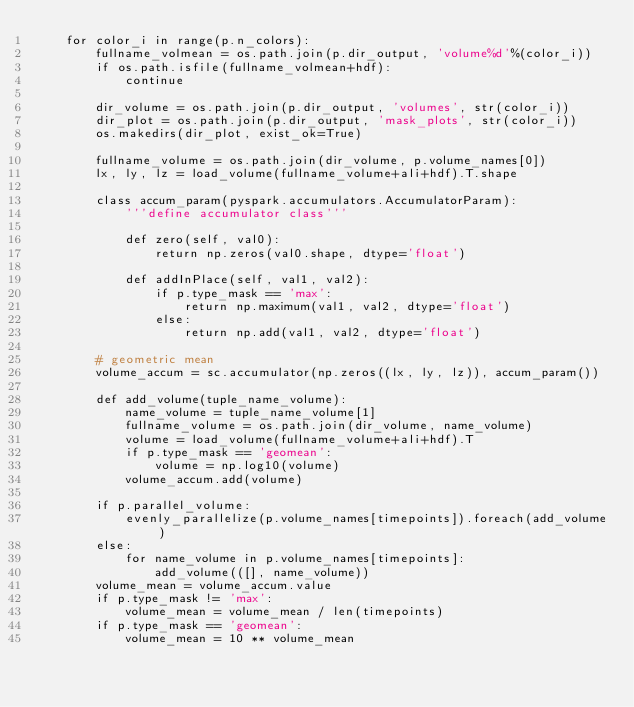<code> <loc_0><loc_0><loc_500><loc_500><_Python_>    for color_i in range(p.n_colors):
        fullname_volmean = os.path.join(p.dir_output, 'volume%d'%(color_i))
        if os.path.isfile(fullname_volmean+hdf):
            continue

        dir_volume = os.path.join(p.dir_output, 'volumes', str(color_i))
        dir_plot = os.path.join(p.dir_output, 'mask_plots', str(color_i))
        os.makedirs(dir_plot, exist_ok=True)

        fullname_volume = os.path.join(dir_volume, p.volume_names[0])
        lx, ly, lz = load_volume(fullname_volume+ali+hdf).T.shape

        class accum_param(pyspark.accumulators.AccumulatorParam):
            '''define accumulator class'''

            def zero(self, val0):
                return np.zeros(val0.shape, dtype='float')

            def addInPlace(self, val1, val2):
                if p.type_mask == 'max':
                    return np.maximum(val1, val2, dtype='float')
                else:
                    return np.add(val1, val2, dtype='float')

        # geometric mean
        volume_accum = sc.accumulator(np.zeros((lx, ly, lz)), accum_param())

        def add_volume(tuple_name_volume):
            name_volume = tuple_name_volume[1]
            fullname_volume = os.path.join(dir_volume, name_volume)
            volume = load_volume(fullname_volume+ali+hdf).T
            if p.type_mask == 'geomean':
                volume = np.log10(volume)
            volume_accum.add(volume)

        if p.parallel_volume:
            evenly_parallelize(p.volume_names[timepoints]).foreach(add_volume)
        else:
            for name_volume in p.volume_names[timepoints]:
                add_volume(([], name_volume))
        volume_mean = volume_accum.value
        if p.type_mask != 'max':
            volume_mean = volume_mean / len(timepoints)
        if p.type_mask == 'geomean':
            volume_mean = 10 ** volume_mean
</code> 